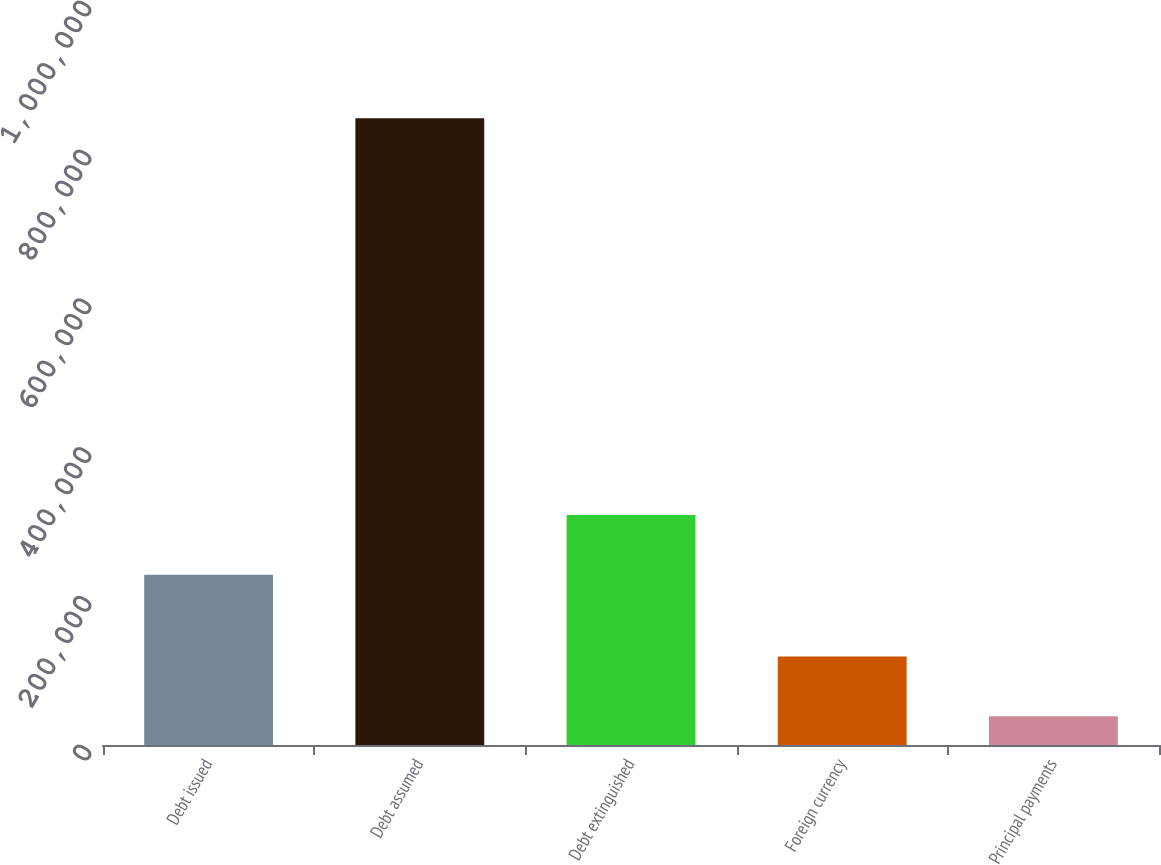Convert chart to OTSL. <chart><loc_0><loc_0><loc_500><loc_500><bar_chart><fcel>Debt issued<fcel>Debt assumed<fcel>Debt extinguished<fcel>Foreign currency<fcel>Principal payments<nl><fcel>228685<fcel>842316<fcel>309048<fcel>119053<fcel>38690<nl></chart> 